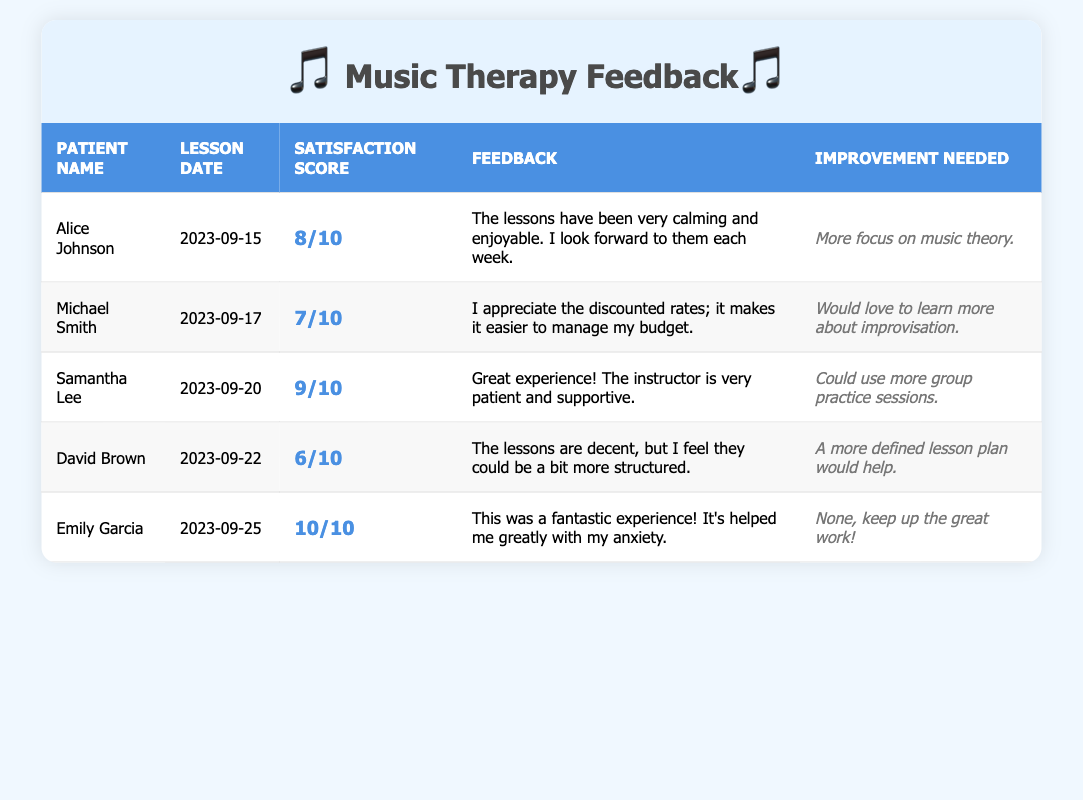What is the satisfaction score of Emily Garcia? According to the table, Emily Garcia's satisfaction score is presented in the relevant column, and it shows a score of 10.
Answer: 10 What feedback did Michael Smith provide regarding the discounted lessons? Looking at Michael Smith's row, his feedback indicates that he appreciates the discounted rates as they make it easier to manage his budget.
Answer: He appreciates the discounted rates What is the average satisfaction score of all patients? To find the average, we first add all the satisfaction scores: 8 + 7 + 9 + 6 + 10 = 40. There are 5 patients, so we divide by 5: 40 / 5 = 8.
Answer: 8 Did any patient request improvement in music theory? By checking the improvement needed column, we see that Alice Johnson mentioned a desire for more focus on music theory, indicating that this fact is true.
Answer: Yes Which patient had the highest satisfaction score and what was their feedback? Scanning through the satisfaction scores, Emily Garcia had the highest score of 10. Her feedback was "This was a fantastic experience! It's helped me greatly with my anxiety."
Answer: Emily Garcia, score 10. Feedback: "Fantastic experience!" What was the improvement request from David Brown? In David Brown's row, the improvement he requested was for a more defined lesson plan to enhance the structure of the lessons.
Answer: A more defined lesson plan How many patients mentioned wanting more practice sessions? By reviewing the feedback in the table, we find that only Samantha Lee requested more group practice sessions, leading to a total of 1 patient.
Answer: 1 patient What is the difference between the highest and lowest satisfaction scores recorded? The highest score is 10 from Emily Garcia, and the lowest is 6 from David Brown. The difference is calculated as 10 - 6 = 4.
Answer: 4 Which patient expressed feeling anxious before the lessons? Emily Garcia mentioned in her feedback that the lessons helped her greatly with her anxiety, thereby indicating that she felt anxious before starting them.
Answer: Emily Garcia 